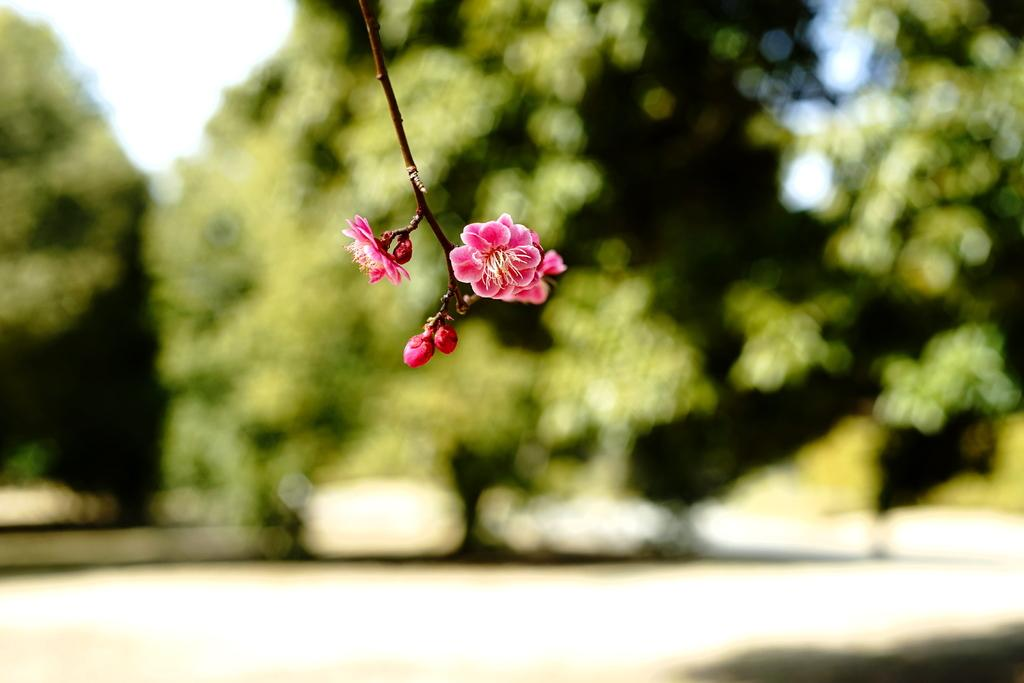What types of plants are in the image? There are flowers and buds in the image. What color are the flowers and buds? The flowers and buds are pink in color. What can be seen in the background of the image? There are trees and the sky visible in the background of the image. How is the background of the image depicted? The background is blurred. What type of instrument is being played by the deer in the image? There are no deer or instruments present in the image. In which direction are the flowers facing in the image? The flowers do not have a specific direction they are facing in the image; they are simply depicted in the scene. 